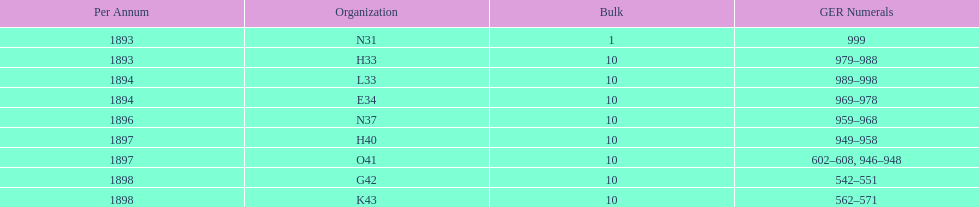Can you give me this table as a dict? {'header': ['Per Annum', 'Organization', 'Bulk', 'GER Numerals'], 'rows': [['1893', 'N31', '1', '999'], ['1893', 'H33', '10', '979–988'], ['1894', 'L33', '10', '989–998'], ['1894', 'E34', '10', '969–978'], ['1896', 'N37', '10', '959–968'], ['1897', 'H40', '10', '949–958'], ['1897', 'O41', '10', '602–608, 946–948'], ['1898', 'G42', '10', '542–551'], ['1898', 'K43', '10', '562–571']]} How mans years have ger nos below 900? 2. 